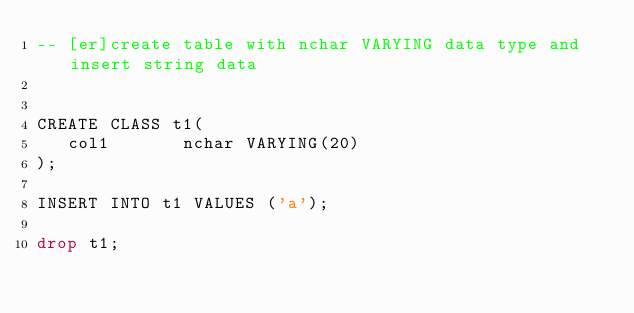Convert code to text. <code><loc_0><loc_0><loc_500><loc_500><_SQL_>-- [er]create table with nchar VARYING data type and insert string data


CREATE CLASS t1(
   col1       nchar VARYING(20)
);

INSERT INTO t1 VALUES ('a');

drop t1;</code> 